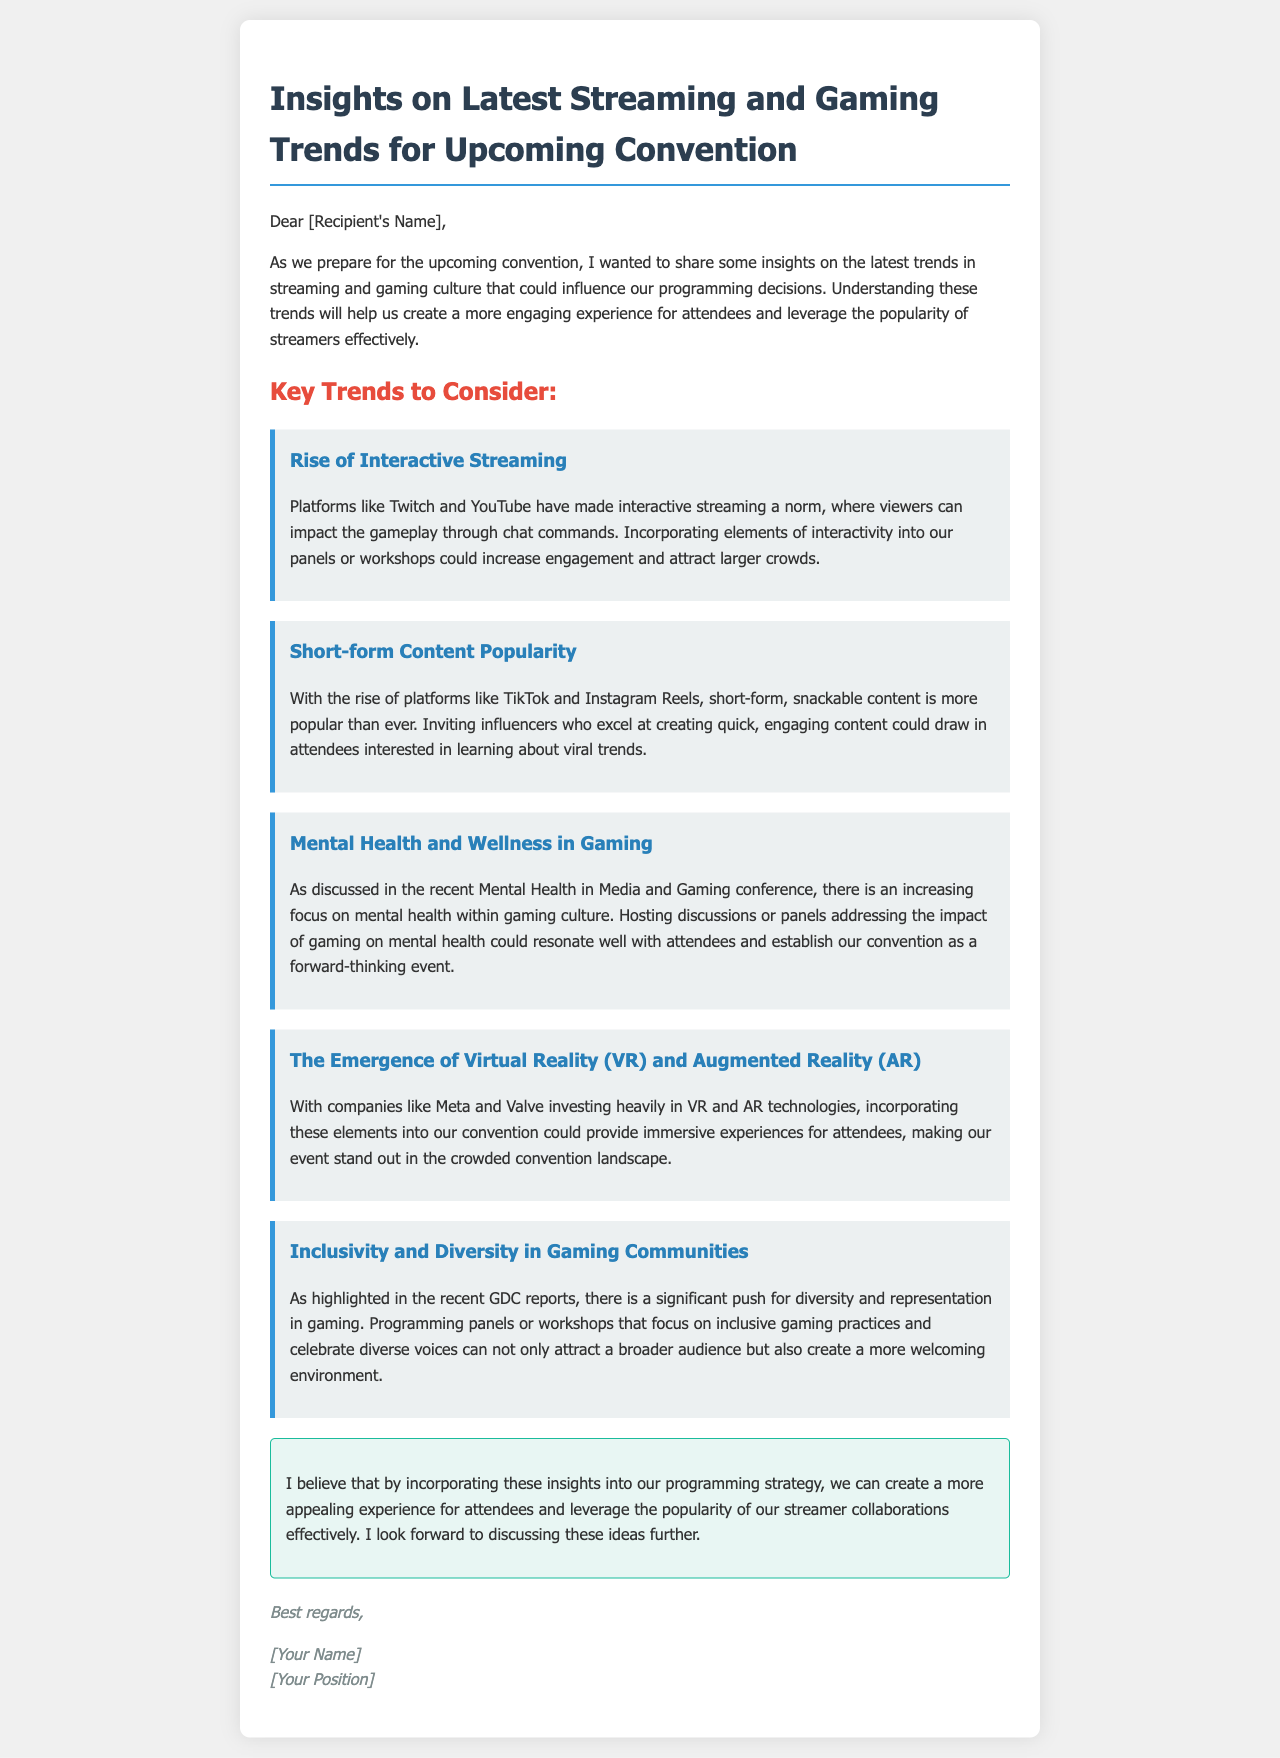What is the first trend mentioned in the email? The first trend discussed is "Rise of Interactive Streaming," which is highlighted in the document.
Answer: Rise of Interactive Streaming What influence does short-form content have on programming? The document suggests inviting influencers who excel at creating quick, engaging content, indicating that it can attract attendees.
Answer: Draw in attendees What is one purpose of discussing mental health in gaming at the convention? The email states that hosting discussions on this topic could resonate well with attendees, making the event forward-thinking.
Answer: Resonating with attendees Which companies are investing in VR and AR technologies according to the email? The document specifically mentions "Meta" and "Valve" as the companies investing heavily in these technologies.
Answer: Meta and Valve What is a key goal for incorporating inclusivity in gaming communities? The email suggests that focusing on inclusive gaming practices can attract a broader audience and create a welcoming environment.
Answer: Broader audience What is the suggested benefit of incorporating interactivity into panels? The trend of interactive streaming indicates that such elements can increase engagement and attract larger crowds.
Answer: Increase engagement 